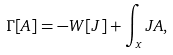Convert formula to latex. <formula><loc_0><loc_0><loc_500><loc_500>\Gamma [ A ] = - W [ J ] + \int _ { x } J A ,</formula> 